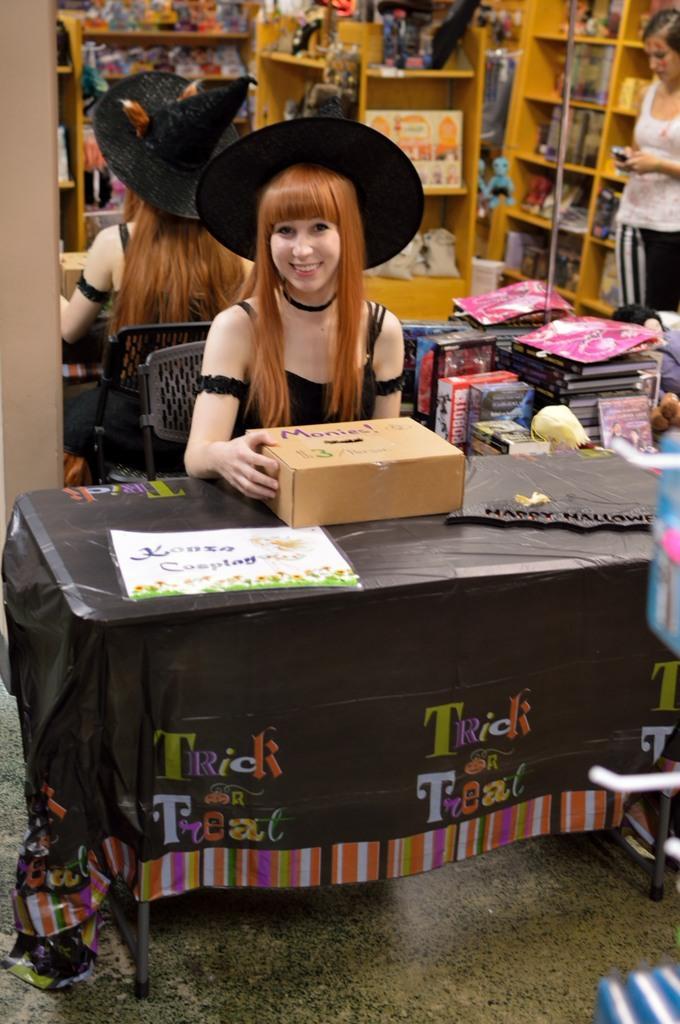Please provide a concise description of this image. On the background we can see a mirror and there is a reflection of racks and there are few things in racks. Here we can see a women wearing black colour hat , sitting on a chair infront fo a table and on the table we can see box, paper and a board. She is a carrying a smile on her face. Here we can see a woman. This is a floor. 